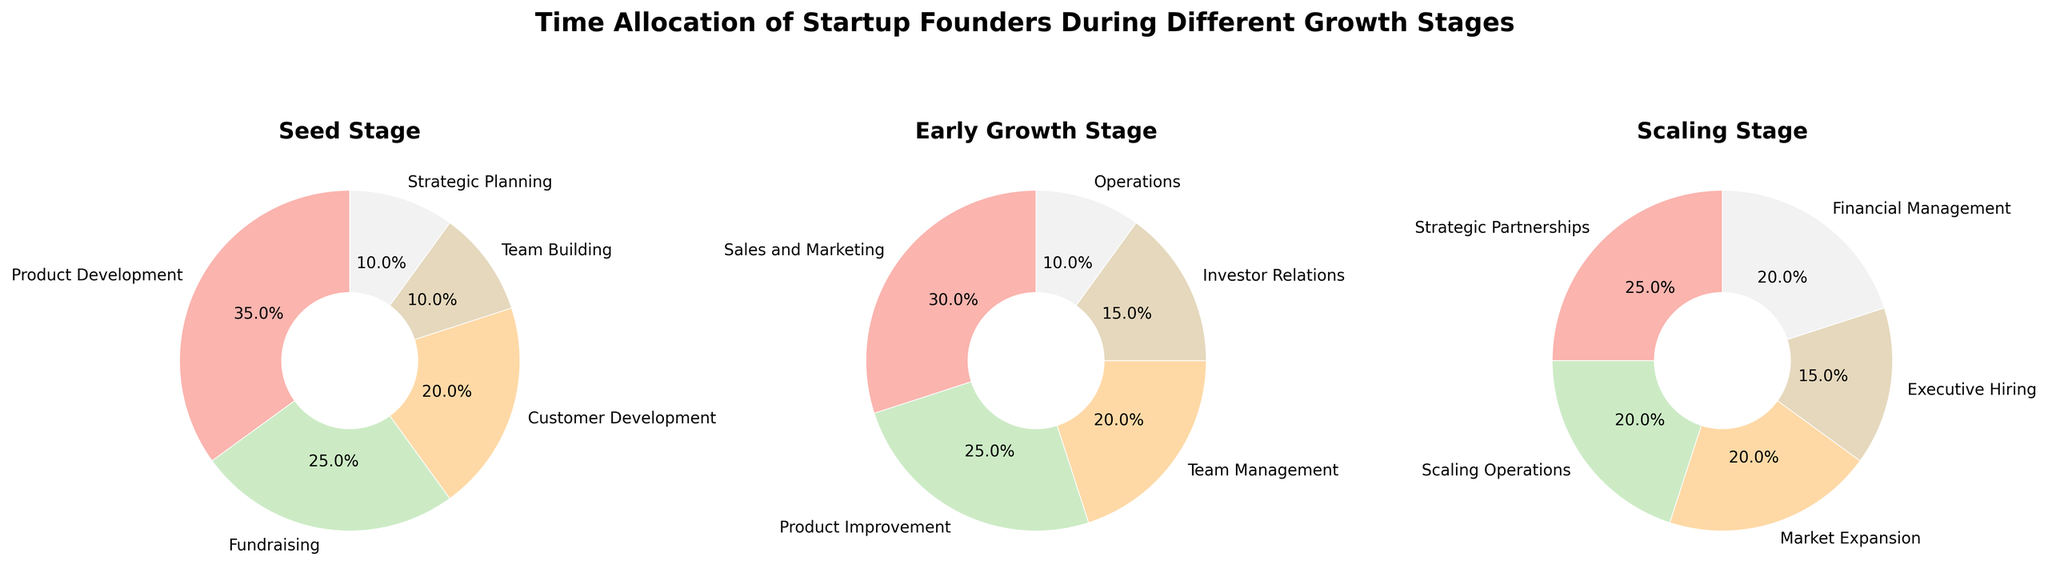What is the activity that takes the largest percentage of time in the Seed stage? In the Seed stage pie chart, identify the activity with the largest wedge size. It is labeled "Product Development" with 35%.
Answer: Product Development Which two activities have the same percentage allocation in the Seed stage and what is their percentage? In the Seed stage pie chart, identify the activities with the same size wedges. "Team Building" and "Strategic Planning" both have 10%.
Answer: Team Building and Strategic Planning; 10% In the Scaling stage, what is the combined percentage of time spent on Strategic Partnerships and Market Expansion? Look at the Scaling stage pie chart and check the slices for "Strategic Partnerships" (25%) and "Market Expansion" (20%). Sum these percentages.
Answer: 45% Which activity gets more time allocation in the Early Growth stage, Sales and Marketing or Product Improvement? In the Early Growth stage pie chart, compare the wedge sizes for "Sales and Marketing" (30%) and "Product Improvement" (25%).
Answer: Sales and Marketing How much more time is spent on Investor Relations in the Early Growth stage compared to the Seed stage? In the Early Growth stage, Investor Relations takes 15%, while in the Seed stage, it isn't listed (0%). Subtract 0% from 15%.
Answer: 15% What are the three activities that take up the largest percentages of time in the Scaling stage, and what are their respective percentages? In the Scaling stage pie chart, identify the three largest wedges: "Strategic Partnerships" (25%), "Scaling Operations" and "Market Expansion" (both 20%).
Answer: Strategic Partnerships: 25%, Scaling Operations: 20%, Market Expansion: 20% During the Seed stage, how much more time is spent on Product Development compared to Fundraising? In the Seed stage pie chart, compare the wedges for Product Development (35%) and Fundraising (25%). Subtract 25 from 35.
Answer: 10% Compare the time allocation for Customer Development in the Seed stage and Market Expansion in the Scaling stage. Which activity takes a higher percentage? In the Seed stage, Customer Development is 20%, whereas Market Expansion in the Scaling stage is also 20%. They have the same percentage.
Answer: Equal What percentage of time is devoted to Executive Hiring in the Scaling stage? In the Scaling stage pie chart, find the wedge for "Executive Hiring" which shows 15%.
Answer: 15% Which stage devotes the most time to team-related activities (Team Building, Team Management, or Executive Hiring) and what is the total percentage? Add the respective team-related activities in each stage: Seed (Team Building: 10%), Early Growth (Team Management: 20%), Scaling (Executive Hiring: 15%). Early Growth has the highest total (20%).
Answer: Early Growth; 20% 